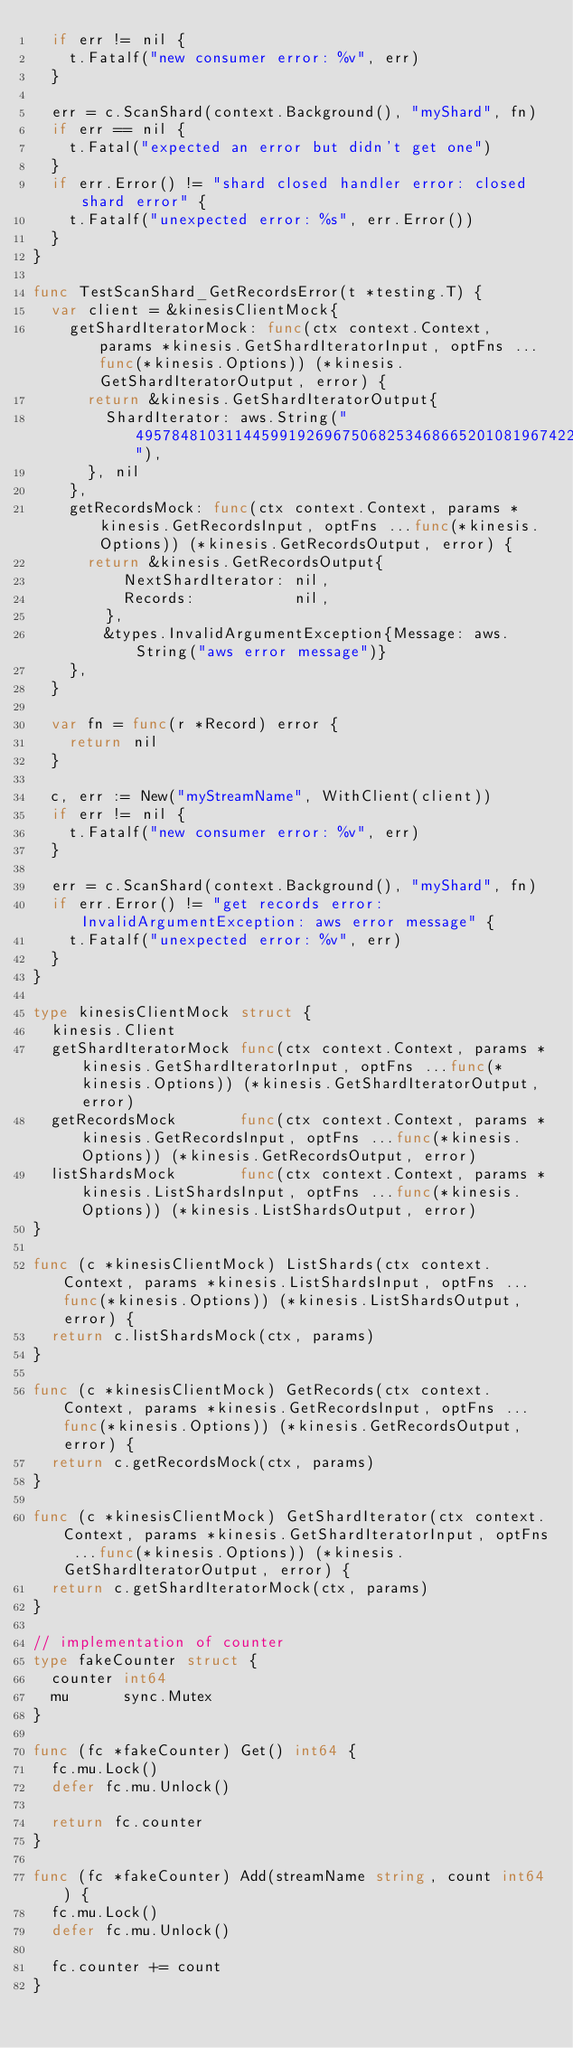<code> <loc_0><loc_0><loc_500><loc_500><_Go_>	if err != nil {
		t.Fatalf("new consumer error: %v", err)
	}

	err = c.ScanShard(context.Background(), "myShard", fn)
	if err == nil {
		t.Fatal("expected an error but didn't get one")
	}
	if err.Error() != "shard closed handler error: closed shard error" {
		t.Fatalf("unexpected error: %s", err.Error())
	}
}

func TestScanShard_GetRecordsError(t *testing.T) {
	var client = &kinesisClientMock{
		getShardIteratorMock: func(ctx context.Context, params *kinesis.GetShardIteratorInput, optFns ...func(*kinesis.Options)) (*kinesis.GetShardIteratorOutput, error) {
			return &kinesis.GetShardIteratorOutput{
				ShardIterator: aws.String("49578481031144599192696750682534686652010819674221576194"),
			}, nil
		},
		getRecordsMock: func(ctx context.Context, params *kinesis.GetRecordsInput, optFns ...func(*kinesis.Options)) (*kinesis.GetRecordsOutput, error) {
			return &kinesis.GetRecordsOutput{
					NextShardIterator: nil,
					Records:           nil,
				},
				&types.InvalidArgumentException{Message: aws.String("aws error message")}
		},
	}

	var fn = func(r *Record) error {
		return nil
	}

	c, err := New("myStreamName", WithClient(client))
	if err != nil {
		t.Fatalf("new consumer error: %v", err)
	}

	err = c.ScanShard(context.Background(), "myShard", fn)
	if err.Error() != "get records error: InvalidArgumentException: aws error message" {
		t.Fatalf("unexpected error: %v", err)
	}
}

type kinesisClientMock struct {
	kinesis.Client
	getShardIteratorMock func(ctx context.Context, params *kinesis.GetShardIteratorInput, optFns ...func(*kinesis.Options)) (*kinesis.GetShardIteratorOutput, error)
	getRecordsMock       func(ctx context.Context, params *kinesis.GetRecordsInput, optFns ...func(*kinesis.Options)) (*kinesis.GetRecordsOutput, error)
	listShardsMock       func(ctx context.Context, params *kinesis.ListShardsInput, optFns ...func(*kinesis.Options)) (*kinesis.ListShardsOutput, error)
}

func (c *kinesisClientMock) ListShards(ctx context.Context, params *kinesis.ListShardsInput, optFns ...func(*kinesis.Options)) (*kinesis.ListShardsOutput, error) {
	return c.listShardsMock(ctx, params)
}

func (c *kinesisClientMock) GetRecords(ctx context.Context, params *kinesis.GetRecordsInput, optFns ...func(*kinesis.Options)) (*kinesis.GetRecordsOutput, error) {
	return c.getRecordsMock(ctx, params)
}

func (c *kinesisClientMock) GetShardIterator(ctx context.Context, params *kinesis.GetShardIteratorInput, optFns ...func(*kinesis.Options)) (*kinesis.GetShardIteratorOutput, error) {
	return c.getShardIteratorMock(ctx, params)
}

// implementation of counter
type fakeCounter struct {
	counter int64
	mu      sync.Mutex
}

func (fc *fakeCounter) Get() int64 {
	fc.mu.Lock()
	defer fc.mu.Unlock()

	return fc.counter
}

func (fc *fakeCounter) Add(streamName string, count int64) {
	fc.mu.Lock()
	defer fc.mu.Unlock()

	fc.counter += count
}
</code> 